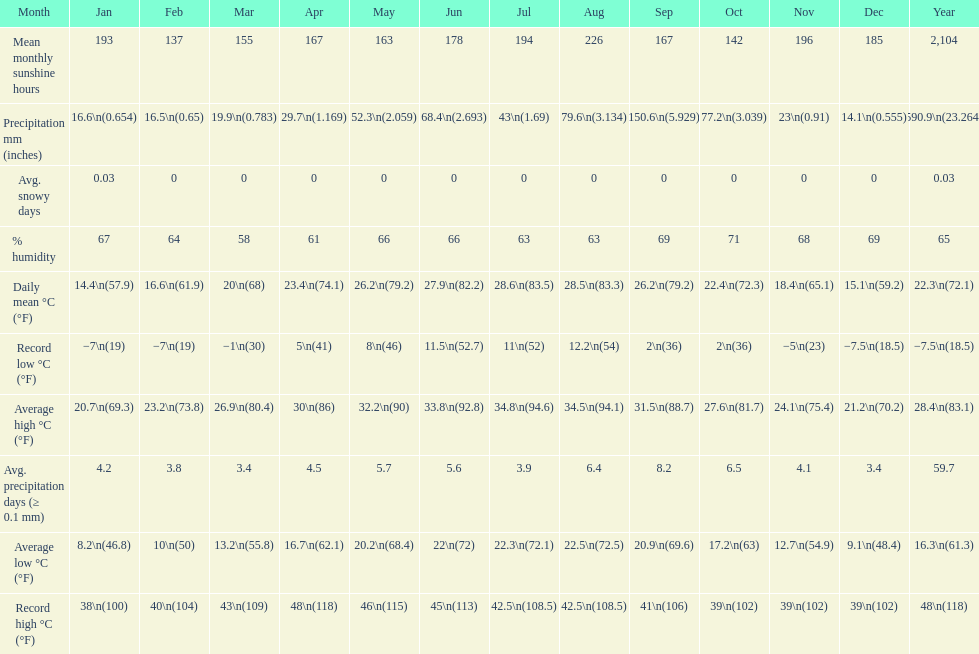Does december or january have more snow days? January. Could you parse the entire table? {'header': ['Month', 'Jan', 'Feb', 'Mar', 'Apr', 'May', 'Jun', 'Jul', 'Aug', 'Sep', 'Oct', 'Nov', 'Dec', 'Year'], 'rows': [['Mean monthly sunshine hours', '193', '137', '155', '167', '163', '178', '194', '226', '167', '142', '196', '185', '2,104'], ['Precipitation mm (inches)', '16.6\\n(0.654)', '16.5\\n(0.65)', '19.9\\n(0.783)', '29.7\\n(1.169)', '52.3\\n(2.059)', '68.4\\n(2.693)', '43\\n(1.69)', '79.6\\n(3.134)', '150.6\\n(5.929)', '77.2\\n(3.039)', '23\\n(0.91)', '14.1\\n(0.555)', '590.9\\n(23.264)'], ['Avg. snowy days', '0.03', '0', '0', '0', '0', '0', '0', '0', '0', '0', '0', '0', '0.03'], ['% humidity', '67', '64', '58', '61', '66', '66', '63', '63', '69', '71', '68', '69', '65'], ['Daily mean °C (°F)', '14.4\\n(57.9)', '16.6\\n(61.9)', '20\\n(68)', '23.4\\n(74.1)', '26.2\\n(79.2)', '27.9\\n(82.2)', '28.6\\n(83.5)', '28.5\\n(83.3)', '26.2\\n(79.2)', '22.4\\n(72.3)', '18.4\\n(65.1)', '15.1\\n(59.2)', '22.3\\n(72.1)'], ['Record low °C (°F)', '−7\\n(19)', '−7\\n(19)', '−1\\n(30)', '5\\n(41)', '8\\n(46)', '11.5\\n(52.7)', '11\\n(52)', '12.2\\n(54)', '2\\n(36)', '2\\n(36)', '−5\\n(23)', '−7.5\\n(18.5)', '−7.5\\n(18.5)'], ['Average high °C (°F)', '20.7\\n(69.3)', '23.2\\n(73.8)', '26.9\\n(80.4)', '30\\n(86)', '32.2\\n(90)', '33.8\\n(92.8)', '34.8\\n(94.6)', '34.5\\n(94.1)', '31.5\\n(88.7)', '27.6\\n(81.7)', '24.1\\n(75.4)', '21.2\\n(70.2)', '28.4\\n(83.1)'], ['Avg. precipitation days (≥ 0.1 mm)', '4.2', '3.8', '3.4', '4.5', '5.7', '5.6', '3.9', '6.4', '8.2', '6.5', '4.1', '3.4', '59.7'], ['Average low °C (°F)', '8.2\\n(46.8)', '10\\n(50)', '13.2\\n(55.8)', '16.7\\n(62.1)', '20.2\\n(68.4)', '22\\n(72)', '22.3\\n(72.1)', '22.5\\n(72.5)', '20.9\\n(69.6)', '17.2\\n(63)', '12.7\\n(54.9)', '9.1\\n(48.4)', '16.3\\n(61.3)'], ['Record high °C (°F)', '38\\n(100)', '40\\n(104)', '43\\n(109)', '48\\n(118)', '46\\n(115)', '45\\n(113)', '42.5\\n(108.5)', '42.5\\n(108.5)', '41\\n(106)', '39\\n(102)', '39\\n(102)', '39\\n(102)', '48\\n(118)']]} 